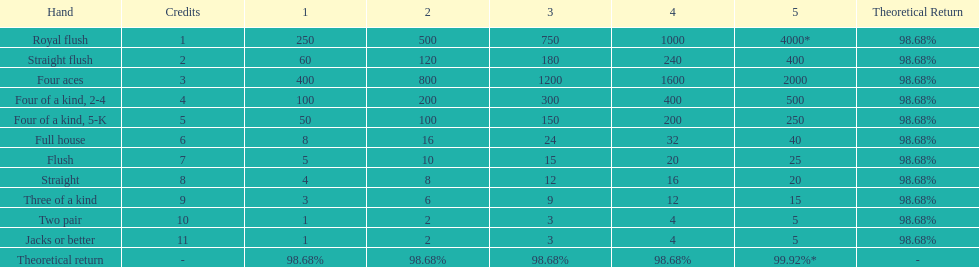At most, what could a person earn for having a full house? 40. 